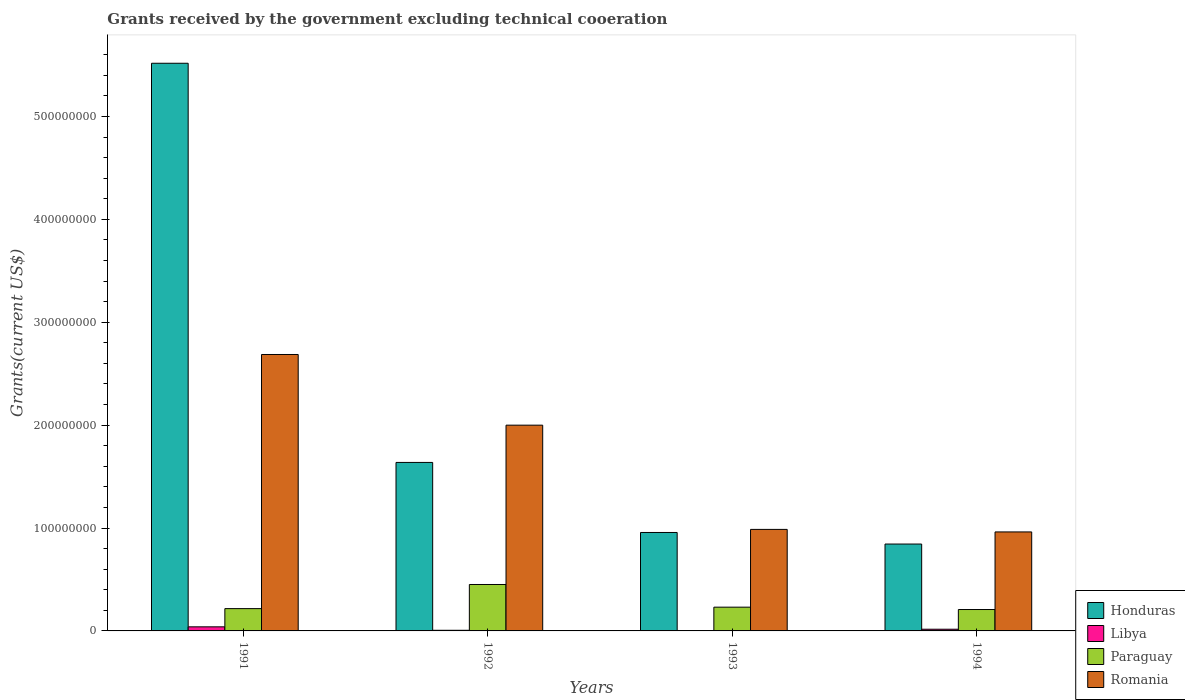How many different coloured bars are there?
Make the answer very short. 4. How many groups of bars are there?
Offer a terse response. 4. Are the number of bars per tick equal to the number of legend labels?
Your response must be concise. Yes. Are the number of bars on each tick of the X-axis equal?
Give a very brief answer. Yes. How many bars are there on the 4th tick from the left?
Make the answer very short. 4. What is the total grants received by the government in Romania in 1994?
Give a very brief answer. 9.62e+07. Across all years, what is the maximum total grants received by the government in Romania?
Give a very brief answer. 2.69e+08. Across all years, what is the minimum total grants received by the government in Romania?
Your response must be concise. 9.62e+07. In which year was the total grants received by the government in Honduras maximum?
Your answer should be compact. 1991. In which year was the total grants received by the government in Paraguay minimum?
Make the answer very short. 1994. What is the total total grants received by the government in Paraguay in the graph?
Your answer should be very brief. 1.11e+08. What is the difference between the total grants received by the government in Paraguay in 1992 and that in 1994?
Your answer should be compact. 2.43e+07. What is the difference between the total grants received by the government in Romania in 1993 and the total grants received by the government in Paraguay in 1991?
Your answer should be very brief. 7.70e+07. What is the average total grants received by the government in Honduras per year?
Make the answer very short. 2.24e+08. In the year 1993, what is the difference between the total grants received by the government in Romania and total grants received by the government in Libya?
Provide a succinct answer. 9.84e+07. In how many years, is the total grants received by the government in Honduras greater than 220000000 US$?
Give a very brief answer. 1. What is the ratio of the total grants received by the government in Romania in 1991 to that in 1993?
Provide a succinct answer. 2.72. Is the total grants received by the government in Romania in 1991 less than that in 1992?
Provide a short and direct response. No. Is the difference between the total grants received by the government in Romania in 1991 and 1992 greater than the difference between the total grants received by the government in Libya in 1991 and 1992?
Keep it short and to the point. Yes. What is the difference between the highest and the second highest total grants received by the government in Paraguay?
Keep it short and to the point. 2.20e+07. What is the difference between the highest and the lowest total grants received by the government in Romania?
Your response must be concise. 1.72e+08. In how many years, is the total grants received by the government in Paraguay greater than the average total grants received by the government in Paraguay taken over all years?
Your answer should be very brief. 1. What does the 2nd bar from the left in 1992 represents?
Offer a very short reply. Libya. What does the 4th bar from the right in 1992 represents?
Your answer should be very brief. Honduras. Is it the case that in every year, the sum of the total grants received by the government in Libya and total grants received by the government in Paraguay is greater than the total grants received by the government in Honduras?
Your response must be concise. No. Does the graph contain grids?
Offer a terse response. No. Where does the legend appear in the graph?
Offer a terse response. Bottom right. How many legend labels are there?
Your answer should be very brief. 4. How are the legend labels stacked?
Provide a succinct answer. Vertical. What is the title of the graph?
Your answer should be very brief. Grants received by the government excluding technical cooeration. Does "India" appear as one of the legend labels in the graph?
Offer a very short reply. No. What is the label or title of the X-axis?
Provide a short and direct response. Years. What is the label or title of the Y-axis?
Provide a short and direct response. Grants(current US$). What is the Grants(current US$) in Honduras in 1991?
Offer a terse response. 5.52e+08. What is the Grants(current US$) of Libya in 1991?
Provide a succinct answer. 3.97e+06. What is the Grants(current US$) of Paraguay in 1991?
Keep it short and to the point. 2.17e+07. What is the Grants(current US$) in Romania in 1991?
Make the answer very short. 2.69e+08. What is the Grants(current US$) of Honduras in 1992?
Give a very brief answer. 1.64e+08. What is the Grants(current US$) of Libya in 1992?
Offer a very short reply. 6.10e+05. What is the Grants(current US$) of Paraguay in 1992?
Ensure brevity in your answer.  4.51e+07. What is the Grants(current US$) of Romania in 1992?
Offer a very short reply. 2.00e+08. What is the Grants(current US$) in Honduras in 1993?
Ensure brevity in your answer.  9.57e+07. What is the Grants(current US$) of Paraguay in 1993?
Keep it short and to the point. 2.31e+07. What is the Grants(current US$) in Romania in 1993?
Ensure brevity in your answer.  9.87e+07. What is the Grants(current US$) in Honduras in 1994?
Your response must be concise. 8.44e+07. What is the Grants(current US$) in Libya in 1994?
Provide a succinct answer. 1.65e+06. What is the Grants(current US$) of Paraguay in 1994?
Your answer should be very brief. 2.08e+07. What is the Grants(current US$) in Romania in 1994?
Your response must be concise. 9.62e+07. Across all years, what is the maximum Grants(current US$) of Honduras?
Your response must be concise. 5.52e+08. Across all years, what is the maximum Grants(current US$) in Libya?
Your answer should be compact. 3.97e+06. Across all years, what is the maximum Grants(current US$) of Paraguay?
Keep it short and to the point. 4.51e+07. Across all years, what is the maximum Grants(current US$) of Romania?
Ensure brevity in your answer.  2.69e+08. Across all years, what is the minimum Grants(current US$) in Honduras?
Provide a succinct answer. 8.44e+07. Across all years, what is the minimum Grants(current US$) in Libya?
Ensure brevity in your answer.  2.80e+05. Across all years, what is the minimum Grants(current US$) in Paraguay?
Keep it short and to the point. 2.08e+07. Across all years, what is the minimum Grants(current US$) of Romania?
Ensure brevity in your answer.  9.62e+07. What is the total Grants(current US$) of Honduras in the graph?
Offer a terse response. 8.96e+08. What is the total Grants(current US$) of Libya in the graph?
Ensure brevity in your answer.  6.51e+06. What is the total Grants(current US$) of Paraguay in the graph?
Provide a succinct answer. 1.11e+08. What is the total Grants(current US$) in Romania in the graph?
Provide a succinct answer. 6.63e+08. What is the difference between the Grants(current US$) of Honduras in 1991 and that in 1992?
Give a very brief answer. 3.88e+08. What is the difference between the Grants(current US$) in Libya in 1991 and that in 1992?
Ensure brevity in your answer.  3.36e+06. What is the difference between the Grants(current US$) of Paraguay in 1991 and that in 1992?
Make the answer very short. -2.34e+07. What is the difference between the Grants(current US$) of Romania in 1991 and that in 1992?
Provide a short and direct response. 6.87e+07. What is the difference between the Grants(current US$) in Honduras in 1991 and that in 1993?
Make the answer very short. 4.56e+08. What is the difference between the Grants(current US$) in Libya in 1991 and that in 1993?
Your answer should be compact. 3.69e+06. What is the difference between the Grants(current US$) of Paraguay in 1991 and that in 1993?
Offer a terse response. -1.41e+06. What is the difference between the Grants(current US$) in Romania in 1991 and that in 1993?
Your answer should be compact. 1.70e+08. What is the difference between the Grants(current US$) in Honduras in 1991 and that in 1994?
Provide a short and direct response. 4.67e+08. What is the difference between the Grants(current US$) of Libya in 1991 and that in 1994?
Provide a short and direct response. 2.32e+06. What is the difference between the Grants(current US$) of Paraguay in 1991 and that in 1994?
Your answer should be very brief. 8.80e+05. What is the difference between the Grants(current US$) of Romania in 1991 and that in 1994?
Your answer should be very brief. 1.72e+08. What is the difference between the Grants(current US$) in Honduras in 1992 and that in 1993?
Keep it short and to the point. 6.81e+07. What is the difference between the Grants(current US$) of Paraguay in 1992 and that in 1993?
Your answer should be very brief. 2.20e+07. What is the difference between the Grants(current US$) of Romania in 1992 and that in 1993?
Provide a short and direct response. 1.01e+08. What is the difference between the Grants(current US$) in Honduras in 1992 and that in 1994?
Provide a succinct answer. 7.93e+07. What is the difference between the Grants(current US$) in Libya in 1992 and that in 1994?
Your answer should be compact. -1.04e+06. What is the difference between the Grants(current US$) of Paraguay in 1992 and that in 1994?
Keep it short and to the point. 2.43e+07. What is the difference between the Grants(current US$) in Romania in 1992 and that in 1994?
Provide a succinct answer. 1.04e+08. What is the difference between the Grants(current US$) of Honduras in 1993 and that in 1994?
Keep it short and to the point. 1.12e+07. What is the difference between the Grants(current US$) in Libya in 1993 and that in 1994?
Make the answer very short. -1.37e+06. What is the difference between the Grants(current US$) in Paraguay in 1993 and that in 1994?
Offer a very short reply. 2.29e+06. What is the difference between the Grants(current US$) of Romania in 1993 and that in 1994?
Your answer should be compact. 2.46e+06. What is the difference between the Grants(current US$) of Honduras in 1991 and the Grants(current US$) of Libya in 1992?
Offer a very short reply. 5.51e+08. What is the difference between the Grants(current US$) of Honduras in 1991 and the Grants(current US$) of Paraguay in 1992?
Your response must be concise. 5.07e+08. What is the difference between the Grants(current US$) in Honduras in 1991 and the Grants(current US$) in Romania in 1992?
Offer a very short reply. 3.52e+08. What is the difference between the Grants(current US$) of Libya in 1991 and the Grants(current US$) of Paraguay in 1992?
Keep it short and to the point. -4.12e+07. What is the difference between the Grants(current US$) in Libya in 1991 and the Grants(current US$) in Romania in 1992?
Offer a very short reply. -1.96e+08. What is the difference between the Grants(current US$) of Paraguay in 1991 and the Grants(current US$) of Romania in 1992?
Give a very brief answer. -1.78e+08. What is the difference between the Grants(current US$) of Honduras in 1991 and the Grants(current US$) of Libya in 1993?
Ensure brevity in your answer.  5.51e+08. What is the difference between the Grants(current US$) of Honduras in 1991 and the Grants(current US$) of Paraguay in 1993?
Make the answer very short. 5.29e+08. What is the difference between the Grants(current US$) of Honduras in 1991 and the Grants(current US$) of Romania in 1993?
Provide a succinct answer. 4.53e+08. What is the difference between the Grants(current US$) of Libya in 1991 and the Grants(current US$) of Paraguay in 1993?
Offer a terse response. -1.91e+07. What is the difference between the Grants(current US$) of Libya in 1991 and the Grants(current US$) of Romania in 1993?
Offer a very short reply. -9.47e+07. What is the difference between the Grants(current US$) of Paraguay in 1991 and the Grants(current US$) of Romania in 1993?
Ensure brevity in your answer.  -7.70e+07. What is the difference between the Grants(current US$) in Honduras in 1991 and the Grants(current US$) in Libya in 1994?
Keep it short and to the point. 5.50e+08. What is the difference between the Grants(current US$) in Honduras in 1991 and the Grants(current US$) in Paraguay in 1994?
Provide a short and direct response. 5.31e+08. What is the difference between the Grants(current US$) of Honduras in 1991 and the Grants(current US$) of Romania in 1994?
Offer a very short reply. 4.55e+08. What is the difference between the Grants(current US$) in Libya in 1991 and the Grants(current US$) in Paraguay in 1994?
Provide a short and direct response. -1.68e+07. What is the difference between the Grants(current US$) in Libya in 1991 and the Grants(current US$) in Romania in 1994?
Your response must be concise. -9.22e+07. What is the difference between the Grants(current US$) of Paraguay in 1991 and the Grants(current US$) of Romania in 1994?
Ensure brevity in your answer.  -7.45e+07. What is the difference between the Grants(current US$) in Honduras in 1992 and the Grants(current US$) in Libya in 1993?
Make the answer very short. 1.63e+08. What is the difference between the Grants(current US$) in Honduras in 1992 and the Grants(current US$) in Paraguay in 1993?
Ensure brevity in your answer.  1.41e+08. What is the difference between the Grants(current US$) in Honduras in 1992 and the Grants(current US$) in Romania in 1993?
Your response must be concise. 6.51e+07. What is the difference between the Grants(current US$) in Libya in 1992 and the Grants(current US$) in Paraguay in 1993?
Your answer should be very brief. -2.25e+07. What is the difference between the Grants(current US$) in Libya in 1992 and the Grants(current US$) in Romania in 1993?
Offer a terse response. -9.81e+07. What is the difference between the Grants(current US$) in Paraguay in 1992 and the Grants(current US$) in Romania in 1993?
Make the answer very short. -5.35e+07. What is the difference between the Grants(current US$) of Honduras in 1992 and the Grants(current US$) of Libya in 1994?
Your answer should be very brief. 1.62e+08. What is the difference between the Grants(current US$) of Honduras in 1992 and the Grants(current US$) of Paraguay in 1994?
Offer a very short reply. 1.43e+08. What is the difference between the Grants(current US$) of Honduras in 1992 and the Grants(current US$) of Romania in 1994?
Offer a very short reply. 6.75e+07. What is the difference between the Grants(current US$) of Libya in 1992 and the Grants(current US$) of Paraguay in 1994?
Your response must be concise. -2.02e+07. What is the difference between the Grants(current US$) of Libya in 1992 and the Grants(current US$) of Romania in 1994?
Make the answer very short. -9.56e+07. What is the difference between the Grants(current US$) in Paraguay in 1992 and the Grants(current US$) in Romania in 1994?
Ensure brevity in your answer.  -5.11e+07. What is the difference between the Grants(current US$) of Honduras in 1993 and the Grants(current US$) of Libya in 1994?
Provide a succinct answer. 9.40e+07. What is the difference between the Grants(current US$) in Honduras in 1993 and the Grants(current US$) in Paraguay in 1994?
Give a very brief answer. 7.49e+07. What is the difference between the Grants(current US$) in Honduras in 1993 and the Grants(current US$) in Romania in 1994?
Offer a terse response. -5.30e+05. What is the difference between the Grants(current US$) in Libya in 1993 and the Grants(current US$) in Paraguay in 1994?
Ensure brevity in your answer.  -2.05e+07. What is the difference between the Grants(current US$) of Libya in 1993 and the Grants(current US$) of Romania in 1994?
Offer a terse response. -9.59e+07. What is the difference between the Grants(current US$) of Paraguay in 1993 and the Grants(current US$) of Romania in 1994?
Your answer should be compact. -7.31e+07. What is the average Grants(current US$) of Honduras per year?
Provide a short and direct response. 2.24e+08. What is the average Grants(current US$) of Libya per year?
Keep it short and to the point. 1.63e+06. What is the average Grants(current US$) in Paraguay per year?
Make the answer very short. 2.77e+07. What is the average Grants(current US$) of Romania per year?
Give a very brief answer. 1.66e+08. In the year 1991, what is the difference between the Grants(current US$) of Honduras and Grants(current US$) of Libya?
Offer a terse response. 5.48e+08. In the year 1991, what is the difference between the Grants(current US$) in Honduras and Grants(current US$) in Paraguay?
Give a very brief answer. 5.30e+08. In the year 1991, what is the difference between the Grants(current US$) in Honduras and Grants(current US$) in Romania?
Provide a succinct answer. 2.83e+08. In the year 1991, what is the difference between the Grants(current US$) of Libya and Grants(current US$) of Paraguay?
Give a very brief answer. -1.77e+07. In the year 1991, what is the difference between the Grants(current US$) in Libya and Grants(current US$) in Romania?
Provide a succinct answer. -2.65e+08. In the year 1991, what is the difference between the Grants(current US$) of Paraguay and Grants(current US$) of Romania?
Make the answer very short. -2.47e+08. In the year 1992, what is the difference between the Grants(current US$) of Honduras and Grants(current US$) of Libya?
Give a very brief answer. 1.63e+08. In the year 1992, what is the difference between the Grants(current US$) of Honduras and Grants(current US$) of Paraguay?
Offer a very short reply. 1.19e+08. In the year 1992, what is the difference between the Grants(current US$) of Honduras and Grants(current US$) of Romania?
Your answer should be compact. -3.62e+07. In the year 1992, what is the difference between the Grants(current US$) in Libya and Grants(current US$) in Paraguay?
Your answer should be very brief. -4.45e+07. In the year 1992, what is the difference between the Grants(current US$) in Libya and Grants(current US$) in Romania?
Provide a short and direct response. -1.99e+08. In the year 1992, what is the difference between the Grants(current US$) of Paraguay and Grants(current US$) of Romania?
Give a very brief answer. -1.55e+08. In the year 1993, what is the difference between the Grants(current US$) of Honduras and Grants(current US$) of Libya?
Provide a short and direct response. 9.54e+07. In the year 1993, what is the difference between the Grants(current US$) of Honduras and Grants(current US$) of Paraguay?
Your answer should be compact. 7.26e+07. In the year 1993, what is the difference between the Grants(current US$) of Honduras and Grants(current US$) of Romania?
Offer a terse response. -2.99e+06. In the year 1993, what is the difference between the Grants(current US$) of Libya and Grants(current US$) of Paraguay?
Your answer should be compact. -2.28e+07. In the year 1993, what is the difference between the Grants(current US$) of Libya and Grants(current US$) of Romania?
Offer a terse response. -9.84e+07. In the year 1993, what is the difference between the Grants(current US$) of Paraguay and Grants(current US$) of Romania?
Your answer should be very brief. -7.56e+07. In the year 1994, what is the difference between the Grants(current US$) of Honduras and Grants(current US$) of Libya?
Give a very brief answer. 8.28e+07. In the year 1994, what is the difference between the Grants(current US$) in Honduras and Grants(current US$) in Paraguay?
Offer a terse response. 6.36e+07. In the year 1994, what is the difference between the Grants(current US$) in Honduras and Grants(current US$) in Romania?
Your response must be concise. -1.18e+07. In the year 1994, what is the difference between the Grants(current US$) in Libya and Grants(current US$) in Paraguay?
Provide a short and direct response. -1.92e+07. In the year 1994, what is the difference between the Grants(current US$) of Libya and Grants(current US$) of Romania?
Offer a terse response. -9.46e+07. In the year 1994, what is the difference between the Grants(current US$) of Paraguay and Grants(current US$) of Romania?
Your response must be concise. -7.54e+07. What is the ratio of the Grants(current US$) in Honduras in 1991 to that in 1992?
Provide a succinct answer. 3.37. What is the ratio of the Grants(current US$) in Libya in 1991 to that in 1992?
Provide a short and direct response. 6.51. What is the ratio of the Grants(current US$) of Paraguay in 1991 to that in 1992?
Provide a short and direct response. 0.48. What is the ratio of the Grants(current US$) of Romania in 1991 to that in 1992?
Offer a terse response. 1.34. What is the ratio of the Grants(current US$) of Honduras in 1991 to that in 1993?
Ensure brevity in your answer.  5.77. What is the ratio of the Grants(current US$) in Libya in 1991 to that in 1993?
Provide a short and direct response. 14.18. What is the ratio of the Grants(current US$) in Paraguay in 1991 to that in 1993?
Provide a succinct answer. 0.94. What is the ratio of the Grants(current US$) of Romania in 1991 to that in 1993?
Your response must be concise. 2.72. What is the ratio of the Grants(current US$) in Honduras in 1991 to that in 1994?
Offer a very short reply. 6.53. What is the ratio of the Grants(current US$) of Libya in 1991 to that in 1994?
Your response must be concise. 2.41. What is the ratio of the Grants(current US$) of Paraguay in 1991 to that in 1994?
Offer a very short reply. 1.04. What is the ratio of the Grants(current US$) in Romania in 1991 to that in 1994?
Make the answer very short. 2.79. What is the ratio of the Grants(current US$) in Honduras in 1992 to that in 1993?
Your answer should be very brief. 1.71. What is the ratio of the Grants(current US$) of Libya in 1992 to that in 1993?
Ensure brevity in your answer.  2.18. What is the ratio of the Grants(current US$) in Paraguay in 1992 to that in 1993?
Give a very brief answer. 1.95. What is the ratio of the Grants(current US$) in Romania in 1992 to that in 1993?
Provide a short and direct response. 2.03. What is the ratio of the Grants(current US$) in Honduras in 1992 to that in 1994?
Give a very brief answer. 1.94. What is the ratio of the Grants(current US$) in Libya in 1992 to that in 1994?
Make the answer very short. 0.37. What is the ratio of the Grants(current US$) of Paraguay in 1992 to that in 1994?
Your response must be concise. 2.17. What is the ratio of the Grants(current US$) in Romania in 1992 to that in 1994?
Provide a short and direct response. 2.08. What is the ratio of the Grants(current US$) in Honduras in 1993 to that in 1994?
Provide a succinct answer. 1.13. What is the ratio of the Grants(current US$) of Libya in 1993 to that in 1994?
Your response must be concise. 0.17. What is the ratio of the Grants(current US$) in Paraguay in 1993 to that in 1994?
Your answer should be very brief. 1.11. What is the ratio of the Grants(current US$) in Romania in 1993 to that in 1994?
Give a very brief answer. 1.03. What is the difference between the highest and the second highest Grants(current US$) of Honduras?
Offer a very short reply. 3.88e+08. What is the difference between the highest and the second highest Grants(current US$) of Libya?
Offer a very short reply. 2.32e+06. What is the difference between the highest and the second highest Grants(current US$) in Paraguay?
Make the answer very short. 2.20e+07. What is the difference between the highest and the second highest Grants(current US$) in Romania?
Offer a very short reply. 6.87e+07. What is the difference between the highest and the lowest Grants(current US$) in Honduras?
Offer a terse response. 4.67e+08. What is the difference between the highest and the lowest Grants(current US$) in Libya?
Provide a succinct answer. 3.69e+06. What is the difference between the highest and the lowest Grants(current US$) of Paraguay?
Offer a very short reply. 2.43e+07. What is the difference between the highest and the lowest Grants(current US$) of Romania?
Your response must be concise. 1.72e+08. 